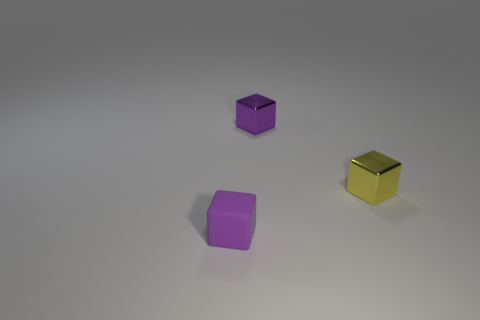How many large things are either gray spheres or yellow cubes?
Offer a very short reply. 0. What is the size of the yellow shiny block?
Your response must be concise. Small. Are there more small purple things that are in front of the tiny yellow metallic object than big yellow matte blocks?
Provide a succinct answer. Yes. Are there the same number of purple blocks to the left of the tiny purple shiny object and yellow metal blocks left of the small matte block?
Offer a terse response. No. There is a object that is in front of the purple metal block and to the left of the yellow block; what color is it?
Make the answer very short. Purple. Are there any other things that are the same size as the purple metal thing?
Offer a very short reply. Yes. Are there more small objects on the right side of the small yellow shiny object than small purple matte objects that are to the right of the purple matte thing?
Ensure brevity in your answer.  No. There is a purple object that is right of the purple rubber thing; does it have the same size as the yellow shiny block?
Your response must be concise. Yes. How many purple matte blocks are in front of the small purple block in front of the purple cube behind the small yellow metal cube?
Offer a terse response. 0. There is a thing that is both to the left of the tiny yellow block and right of the tiny matte object; what is its size?
Ensure brevity in your answer.  Small. 